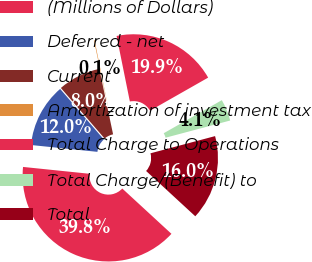Convert chart. <chart><loc_0><loc_0><loc_500><loc_500><pie_chart><fcel>(Millions of Dollars)<fcel>Deferred - net<fcel>Current<fcel>Amortization of investment tax<fcel>Total Charge to Operations<fcel>Total Charge/(Benefit) to<fcel>Total<nl><fcel>39.79%<fcel>12.02%<fcel>8.05%<fcel>0.12%<fcel>19.95%<fcel>4.09%<fcel>15.99%<nl></chart> 